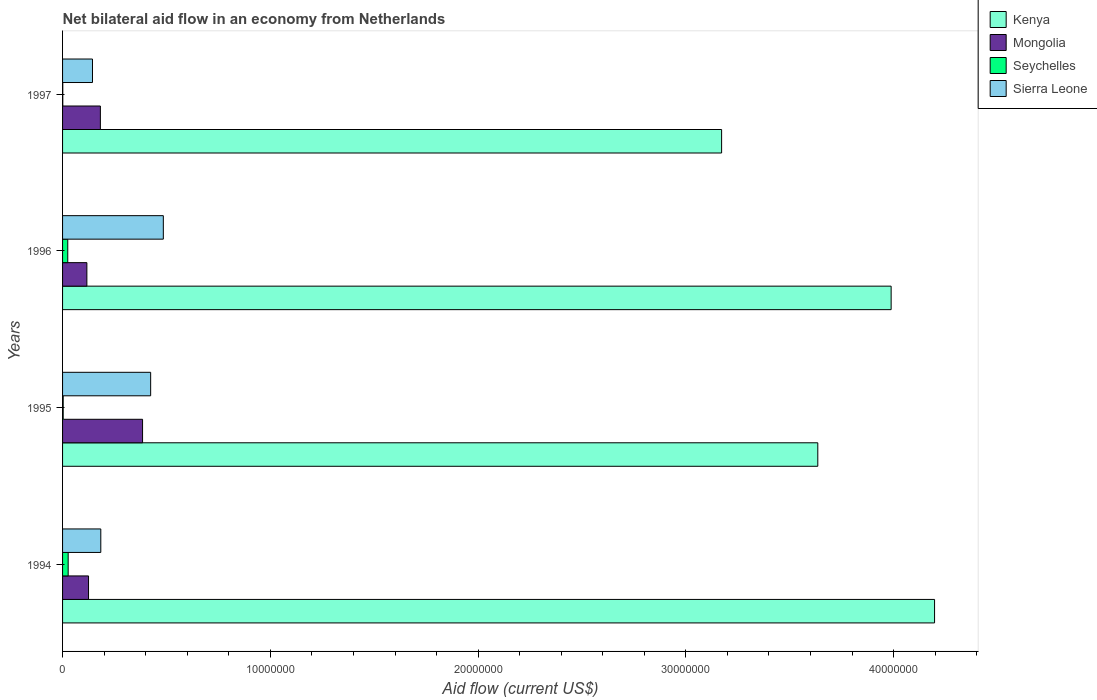How many groups of bars are there?
Your response must be concise. 4. How many bars are there on the 3rd tick from the bottom?
Keep it short and to the point. 4. What is the net bilateral aid flow in Mongolia in 1995?
Keep it short and to the point. 3.85e+06. Across all years, what is the maximum net bilateral aid flow in Kenya?
Provide a succinct answer. 4.20e+07. Across all years, what is the minimum net bilateral aid flow in Kenya?
Provide a succinct answer. 3.17e+07. In which year was the net bilateral aid flow in Sierra Leone minimum?
Ensure brevity in your answer.  1997. What is the total net bilateral aid flow in Kenya in the graph?
Your answer should be very brief. 1.50e+08. What is the difference between the net bilateral aid flow in Sierra Leone in 1994 and that in 1996?
Give a very brief answer. -3.01e+06. What is the difference between the net bilateral aid flow in Seychelles in 1996 and the net bilateral aid flow in Kenya in 1995?
Ensure brevity in your answer.  -3.61e+07. What is the average net bilateral aid flow in Seychelles per year?
Your answer should be very brief. 1.40e+05. In the year 1996, what is the difference between the net bilateral aid flow in Sierra Leone and net bilateral aid flow in Mongolia?
Provide a short and direct response. 3.68e+06. What is the ratio of the net bilateral aid flow in Mongolia in 1994 to that in 1996?
Offer a terse response. 1.07. Is the net bilateral aid flow in Mongolia in 1994 less than that in 1996?
Provide a succinct answer. No. Is the difference between the net bilateral aid flow in Sierra Leone in 1994 and 1995 greater than the difference between the net bilateral aid flow in Mongolia in 1994 and 1995?
Keep it short and to the point. Yes. What is the difference between the highest and the second highest net bilateral aid flow in Mongolia?
Offer a very short reply. 2.03e+06. What is the difference between the highest and the lowest net bilateral aid flow in Mongolia?
Give a very brief answer. 2.68e+06. In how many years, is the net bilateral aid flow in Seychelles greater than the average net bilateral aid flow in Seychelles taken over all years?
Offer a terse response. 2. Is it the case that in every year, the sum of the net bilateral aid flow in Mongolia and net bilateral aid flow in Seychelles is greater than the sum of net bilateral aid flow in Kenya and net bilateral aid flow in Sierra Leone?
Offer a terse response. No. What does the 3rd bar from the top in 1997 represents?
Provide a short and direct response. Mongolia. What does the 2nd bar from the bottom in 1996 represents?
Make the answer very short. Mongolia. Is it the case that in every year, the sum of the net bilateral aid flow in Seychelles and net bilateral aid flow in Sierra Leone is greater than the net bilateral aid flow in Kenya?
Your answer should be very brief. No. How many bars are there?
Your answer should be compact. 16. Does the graph contain any zero values?
Give a very brief answer. No. How many legend labels are there?
Your answer should be compact. 4. What is the title of the graph?
Give a very brief answer. Net bilateral aid flow in an economy from Netherlands. Does "Croatia" appear as one of the legend labels in the graph?
Your answer should be very brief. No. What is the label or title of the X-axis?
Keep it short and to the point. Aid flow (current US$). What is the label or title of the Y-axis?
Make the answer very short. Years. What is the Aid flow (current US$) of Kenya in 1994?
Ensure brevity in your answer.  4.20e+07. What is the Aid flow (current US$) in Mongolia in 1994?
Offer a terse response. 1.25e+06. What is the Aid flow (current US$) of Sierra Leone in 1994?
Keep it short and to the point. 1.84e+06. What is the Aid flow (current US$) in Kenya in 1995?
Make the answer very short. 3.64e+07. What is the Aid flow (current US$) of Mongolia in 1995?
Your answer should be compact. 3.85e+06. What is the Aid flow (current US$) in Seychelles in 1995?
Your answer should be compact. 3.00e+04. What is the Aid flow (current US$) in Sierra Leone in 1995?
Make the answer very short. 4.24e+06. What is the Aid flow (current US$) in Kenya in 1996?
Your answer should be compact. 3.99e+07. What is the Aid flow (current US$) in Mongolia in 1996?
Your response must be concise. 1.17e+06. What is the Aid flow (current US$) of Sierra Leone in 1996?
Keep it short and to the point. 4.85e+06. What is the Aid flow (current US$) in Kenya in 1997?
Offer a terse response. 3.17e+07. What is the Aid flow (current US$) of Mongolia in 1997?
Give a very brief answer. 1.82e+06. What is the Aid flow (current US$) in Seychelles in 1997?
Ensure brevity in your answer.  10000. What is the Aid flow (current US$) of Sierra Leone in 1997?
Offer a terse response. 1.44e+06. Across all years, what is the maximum Aid flow (current US$) in Kenya?
Keep it short and to the point. 4.20e+07. Across all years, what is the maximum Aid flow (current US$) in Mongolia?
Make the answer very short. 3.85e+06. Across all years, what is the maximum Aid flow (current US$) in Seychelles?
Your answer should be compact. 2.70e+05. Across all years, what is the maximum Aid flow (current US$) of Sierra Leone?
Offer a terse response. 4.85e+06. Across all years, what is the minimum Aid flow (current US$) of Kenya?
Keep it short and to the point. 3.17e+07. Across all years, what is the minimum Aid flow (current US$) in Mongolia?
Ensure brevity in your answer.  1.17e+06. Across all years, what is the minimum Aid flow (current US$) of Sierra Leone?
Your response must be concise. 1.44e+06. What is the total Aid flow (current US$) of Kenya in the graph?
Keep it short and to the point. 1.50e+08. What is the total Aid flow (current US$) of Mongolia in the graph?
Keep it short and to the point. 8.09e+06. What is the total Aid flow (current US$) of Seychelles in the graph?
Offer a terse response. 5.60e+05. What is the total Aid flow (current US$) of Sierra Leone in the graph?
Your answer should be compact. 1.24e+07. What is the difference between the Aid flow (current US$) in Kenya in 1994 and that in 1995?
Ensure brevity in your answer.  5.62e+06. What is the difference between the Aid flow (current US$) in Mongolia in 1994 and that in 1995?
Your answer should be very brief. -2.60e+06. What is the difference between the Aid flow (current US$) of Sierra Leone in 1994 and that in 1995?
Provide a succinct answer. -2.40e+06. What is the difference between the Aid flow (current US$) of Kenya in 1994 and that in 1996?
Give a very brief answer. 2.09e+06. What is the difference between the Aid flow (current US$) in Mongolia in 1994 and that in 1996?
Provide a short and direct response. 8.00e+04. What is the difference between the Aid flow (current US$) of Seychelles in 1994 and that in 1996?
Make the answer very short. 2.00e+04. What is the difference between the Aid flow (current US$) in Sierra Leone in 1994 and that in 1996?
Offer a very short reply. -3.01e+06. What is the difference between the Aid flow (current US$) of Kenya in 1994 and that in 1997?
Your answer should be compact. 1.02e+07. What is the difference between the Aid flow (current US$) in Mongolia in 1994 and that in 1997?
Make the answer very short. -5.70e+05. What is the difference between the Aid flow (current US$) of Sierra Leone in 1994 and that in 1997?
Give a very brief answer. 4.00e+05. What is the difference between the Aid flow (current US$) in Kenya in 1995 and that in 1996?
Give a very brief answer. -3.53e+06. What is the difference between the Aid flow (current US$) of Mongolia in 1995 and that in 1996?
Provide a succinct answer. 2.68e+06. What is the difference between the Aid flow (current US$) of Seychelles in 1995 and that in 1996?
Offer a terse response. -2.20e+05. What is the difference between the Aid flow (current US$) of Sierra Leone in 1995 and that in 1996?
Give a very brief answer. -6.10e+05. What is the difference between the Aid flow (current US$) of Kenya in 1995 and that in 1997?
Ensure brevity in your answer.  4.63e+06. What is the difference between the Aid flow (current US$) of Mongolia in 1995 and that in 1997?
Make the answer very short. 2.03e+06. What is the difference between the Aid flow (current US$) of Sierra Leone in 1995 and that in 1997?
Keep it short and to the point. 2.80e+06. What is the difference between the Aid flow (current US$) in Kenya in 1996 and that in 1997?
Ensure brevity in your answer.  8.16e+06. What is the difference between the Aid flow (current US$) of Mongolia in 1996 and that in 1997?
Give a very brief answer. -6.50e+05. What is the difference between the Aid flow (current US$) of Seychelles in 1996 and that in 1997?
Offer a very short reply. 2.40e+05. What is the difference between the Aid flow (current US$) of Sierra Leone in 1996 and that in 1997?
Your answer should be compact. 3.41e+06. What is the difference between the Aid flow (current US$) of Kenya in 1994 and the Aid flow (current US$) of Mongolia in 1995?
Keep it short and to the point. 3.81e+07. What is the difference between the Aid flow (current US$) in Kenya in 1994 and the Aid flow (current US$) in Seychelles in 1995?
Keep it short and to the point. 4.19e+07. What is the difference between the Aid flow (current US$) of Kenya in 1994 and the Aid flow (current US$) of Sierra Leone in 1995?
Give a very brief answer. 3.77e+07. What is the difference between the Aid flow (current US$) of Mongolia in 1994 and the Aid flow (current US$) of Seychelles in 1995?
Your response must be concise. 1.22e+06. What is the difference between the Aid flow (current US$) in Mongolia in 1994 and the Aid flow (current US$) in Sierra Leone in 1995?
Your answer should be very brief. -2.99e+06. What is the difference between the Aid flow (current US$) in Seychelles in 1994 and the Aid flow (current US$) in Sierra Leone in 1995?
Your answer should be very brief. -3.97e+06. What is the difference between the Aid flow (current US$) in Kenya in 1994 and the Aid flow (current US$) in Mongolia in 1996?
Make the answer very short. 4.08e+07. What is the difference between the Aid flow (current US$) of Kenya in 1994 and the Aid flow (current US$) of Seychelles in 1996?
Your answer should be very brief. 4.17e+07. What is the difference between the Aid flow (current US$) in Kenya in 1994 and the Aid flow (current US$) in Sierra Leone in 1996?
Offer a very short reply. 3.71e+07. What is the difference between the Aid flow (current US$) of Mongolia in 1994 and the Aid flow (current US$) of Sierra Leone in 1996?
Provide a succinct answer. -3.60e+06. What is the difference between the Aid flow (current US$) in Seychelles in 1994 and the Aid flow (current US$) in Sierra Leone in 1996?
Provide a succinct answer. -4.58e+06. What is the difference between the Aid flow (current US$) of Kenya in 1994 and the Aid flow (current US$) of Mongolia in 1997?
Offer a very short reply. 4.02e+07. What is the difference between the Aid flow (current US$) in Kenya in 1994 and the Aid flow (current US$) in Seychelles in 1997?
Make the answer very short. 4.20e+07. What is the difference between the Aid flow (current US$) of Kenya in 1994 and the Aid flow (current US$) of Sierra Leone in 1997?
Your answer should be compact. 4.05e+07. What is the difference between the Aid flow (current US$) in Mongolia in 1994 and the Aid flow (current US$) in Seychelles in 1997?
Make the answer very short. 1.24e+06. What is the difference between the Aid flow (current US$) of Mongolia in 1994 and the Aid flow (current US$) of Sierra Leone in 1997?
Offer a very short reply. -1.90e+05. What is the difference between the Aid flow (current US$) of Seychelles in 1994 and the Aid flow (current US$) of Sierra Leone in 1997?
Provide a short and direct response. -1.17e+06. What is the difference between the Aid flow (current US$) in Kenya in 1995 and the Aid flow (current US$) in Mongolia in 1996?
Your answer should be compact. 3.52e+07. What is the difference between the Aid flow (current US$) in Kenya in 1995 and the Aid flow (current US$) in Seychelles in 1996?
Give a very brief answer. 3.61e+07. What is the difference between the Aid flow (current US$) of Kenya in 1995 and the Aid flow (current US$) of Sierra Leone in 1996?
Your response must be concise. 3.15e+07. What is the difference between the Aid flow (current US$) of Mongolia in 1995 and the Aid flow (current US$) of Seychelles in 1996?
Provide a succinct answer. 3.60e+06. What is the difference between the Aid flow (current US$) in Seychelles in 1995 and the Aid flow (current US$) in Sierra Leone in 1996?
Give a very brief answer. -4.82e+06. What is the difference between the Aid flow (current US$) of Kenya in 1995 and the Aid flow (current US$) of Mongolia in 1997?
Offer a terse response. 3.45e+07. What is the difference between the Aid flow (current US$) in Kenya in 1995 and the Aid flow (current US$) in Seychelles in 1997?
Your answer should be compact. 3.63e+07. What is the difference between the Aid flow (current US$) of Kenya in 1995 and the Aid flow (current US$) of Sierra Leone in 1997?
Give a very brief answer. 3.49e+07. What is the difference between the Aid flow (current US$) of Mongolia in 1995 and the Aid flow (current US$) of Seychelles in 1997?
Provide a short and direct response. 3.84e+06. What is the difference between the Aid flow (current US$) in Mongolia in 1995 and the Aid flow (current US$) in Sierra Leone in 1997?
Your response must be concise. 2.41e+06. What is the difference between the Aid flow (current US$) in Seychelles in 1995 and the Aid flow (current US$) in Sierra Leone in 1997?
Your response must be concise. -1.41e+06. What is the difference between the Aid flow (current US$) in Kenya in 1996 and the Aid flow (current US$) in Mongolia in 1997?
Your answer should be very brief. 3.81e+07. What is the difference between the Aid flow (current US$) in Kenya in 1996 and the Aid flow (current US$) in Seychelles in 1997?
Make the answer very short. 3.99e+07. What is the difference between the Aid flow (current US$) of Kenya in 1996 and the Aid flow (current US$) of Sierra Leone in 1997?
Provide a succinct answer. 3.84e+07. What is the difference between the Aid flow (current US$) of Mongolia in 1996 and the Aid flow (current US$) of Seychelles in 1997?
Give a very brief answer. 1.16e+06. What is the difference between the Aid flow (current US$) in Seychelles in 1996 and the Aid flow (current US$) in Sierra Leone in 1997?
Ensure brevity in your answer.  -1.19e+06. What is the average Aid flow (current US$) in Kenya per year?
Provide a succinct answer. 3.75e+07. What is the average Aid flow (current US$) in Mongolia per year?
Make the answer very short. 2.02e+06. What is the average Aid flow (current US$) of Seychelles per year?
Give a very brief answer. 1.40e+05. What is the average Aid flow (current US$) of Sierra Leone per year?
Your answer should be very brief. 3.09e+06. In the year 1994, what is the difference between the Aid flow (current US$) in Kenya and Aid flow (current US$) in Mongolia?
Provide a short and direct response. 4.07e+07. In the year 1994, what is the difference between the Aid flow (current US$) in Kenya and Aid flow (current US$) in Seychelles?
Keep it short and to the point. 4.17e+07. In the year 1994, what is the difference between the Aid flow (current US$) in Kenya and Aid flow (current US$) in Sierra Leone?
Make the answer very short. 4.01e+07. In the year 1994, what is the difference between the Aid flow (current US$) of Mongolia and Aid flow (current US$) of Seychelles?
Provide a succinct answer. 9.80e+05. In the year 1994, what is the difference between the Aid flow (current US$) in Mongolia and Aid flow (current US$) in Sierra Leone?
Provide a short and direct response. -5.90e+05. In the year 1994, what is the difference between the Aid flow (current US$) of Seychelles and Aid flow (current US$) of Sierra Leone?
Keep it short and to the point. -1.57e+06. In the year 1995, what is the difference between the Aid flow (current US$) in Kenya and Aid flow (current US$) in Mongolia?
Your answer should be compact. 3.25e+07. In the year 1995, what is the difference between the Aid flow (current US$) in Kenya and Aid flow (current US$) in Seychelles?
Keep it short and to the point. 3.63e+07. In the year 1995, what is the difference between the Aid flow (current US$) of Kenya and Aid flow (current US$) of Sierra Leone?
Make the answer very short. 3.21e+07. In the year 1995, what is the difference between the Aid flow (current US$) of Mongolia and Aid flow (current US$) of Seychelles?
Your answer should be compact. 3.82e+06. In the year 1995, what is the difference between the Aid flow (current US$) in Mongolia and Aid flow (current US$) in Sierra Leone?
Offer a very short reply. -3.90e+05. In the year 1995, what is the difference between the Aid flow (current US$) in Seychelles and Aid flow (current US$) in Sierra Leone?
Offer a terse response. -4.21e+06. In the year 1996, what is the difference between the Aid flow (current US$) in Kenya and Aid flow (current US$) in Mongolia?
Offer a very short reply. 3.87e+07. In the year 1996, what is the difference between the Aid flow (current US$) in Kenya and Aid flow (current US$) in Seychelles?
Your answer should be compact. 3.96e+07. In the year 1996, what is the difference between the Aid flow (current US$) in Kenya and Aid flow (current US$) in Sierra Leone?
Keep it short and to the point. 3.50e+07. In the year 1996, what is the difference between the Aid flow (current US$) of Mongolia and Aid flow (current US$) of Seychelles?
Your answer should be very brief. 9.20e+05. In the year 1996, what is the difference between the Aid flow (current US$) in Mongolia and Aid flow (current US$) in Sierra Leone?
Provide a short and direct response. -3.68e+06. In the year 1996, what is the difference between the Aid flow (current US$) in Seychelles and Aid flow (current US$) in Sierra Leone?
Your answer should be very brief. -4.60e+06. In the year 1997, what is the difference between the Aid flow (current US$) in Kenya and Aid flow (current US$) in Mongolia?
Ensure brevity in your answer.  2.99e+07. In the year 1997, what is the difference between the Aid flow (current US$) in Kenya and Aid flow (current US$) in Seychelles?
Make the answer very short. 3.17e+07. In the year 1997, what is the difference between the Aid flow (current US$) of Kenya and Aid flow (current US$) of Sierra Leone?
Your answer should be very brief. 3.03e+07. In the year 1997, what is the difference between the Aid flow (current US$) in Mongolia and Aid flow (current US$) in Seychelles?
Make the answer very short. 1.81e+06. In the year 1997, what is the difference between the Aid flow (current US$) in Mongolia and Aid flow (current US$) in Sierra Leone?
Your answer should be compact. 3.80e+05. In the year 1997, what is the difference between the Aid flow (current US$) of Seychelles and Aid flow (current US$) of Sierra Leone?
Your answer should be compact. -1.43e+06. What is the ratio of the Aid flow (current US$) of Kenya in 1994 to that in 1995?
Make the answer very short. 1.15. What is the ratio of the Aid flow (current US$) of Mongolia in 1994 to that in 1995?
Your answer should be compact. 0.32. What is the ratio of the Aid flow (current US$) in Seychelles in 1994 to that in 1995?
Offer a terse response. 9. What is the ratio of the Aid flow (current US$) of Sierra Leone in 1994 to that in 1995?
Make the answer very short. 0.43. What is the ratio of the Aid flow (current US$) of Kenya in 1994 to that in 1996?
Your answer should be very brief. 1.05. What is the ratio of the Aid flow (current US$) of Mongolia in 1994 to that in 1996?
Provide a short and direct response. 1.07. What is the ratio of the Aid flow (current US$) of Seychelles in 1994 to that in 1996?
Provide a succinct answer. 1.08. What is the ratio of the Aid flow (current US$) of Sierra Leone in 1994 to that in 1996?
Provide a short and direct response. 0.38. What is the ratio of the Aid flow (current US$) of Kenya in 1994 to that in 1997?
Offer a very short reply. 1.32. What is the ratio of the Aid flow (current US$) in Mongolia in 1994 to that in 1997?
Provide a short and direct response. 0.69. What is the ratio of the Aid flow (current US$) of Seychelles in 1994 to that in 1997?
Ensure brevity in your answer.  27. What is the ratio of the Aid flow (current US$) in Sierra Leone in 1994 to that in 1997?
Offer a terse response. 1.28. What is the ratio of the Aid flow (current US$) of Kenya in 1995 to that in 1996?
Offer a terse response. 0.91. What is the ratio of the Aid flow (current US$) of Mongolia in 1995 to that in 1996?
Your answer should be very brief. 3.29. What is the ratio of the Aid flow (current US$) of Seychelles in 1995 to that in 1996?
Your answer should be very brief. 0.12. What is the ratio of the Aid flow (current US$) of Sierra Leone in 1995 to that in 1996?
Your response must be concise. 0.87. What is the ratio of the Aid flow (current US$) in Kenya in 1995 to that in 1997?
Give a very brief answer. 1.15. What is the ratio of the Aid flow (current US$) of Mongolia in 1995 to that in 1997?
Make the answer very short. 2.12. What is the ratio of the Aid flow (current US$) of Sierra Leone in 1995 to that in 1997?
Give a very brief answer. 2.94. What is the ratio of the Aid flow (current US$) in Kenya in 1996 to that in 1997?
Make the answer very short. 1.26. What is the ratio of the Aid flow (current US$) in Mongolia in 1996 to that in 1997?
Make the answer very short. 0.64. What is the ratio of the Aid flow (current US$) of Seychelles in 1996 to that in 1997?
Your answer should be very brief. 25. What is the ratio of the Aid flow (current US$) in Sierra Leone in 1996 to that in 1997?
Ensure brevity in your answer.  3.37. What is the difference between the highest and the second highest Aid flow (current US$) in Kenya?
Your response must be concise. 2.09e+06. What is the difference between the highest and the second highest Aid flow (current US$) in Mongolia?
Offer a very short reply. 2.03e+06. What is the difference between the highest and the lowest Aid flow (current US$) in Kenya?
Ensure brevity in your answer.  1.02e+07. What is the difference between the highest and the lowest Aid flow (current US$) in Mongolia?
Provide a short and direct response. 2.68e+06. What is the difference between the highest and the lowest Aid flow (current US$) of Seychelles?
Ensure brevity in your answer.  2.60e+05. What is the difference between the highest and the lowest Aid flow (current US$) in Sierra Leone?
Provide a short and direct response. 3.41e+06. 